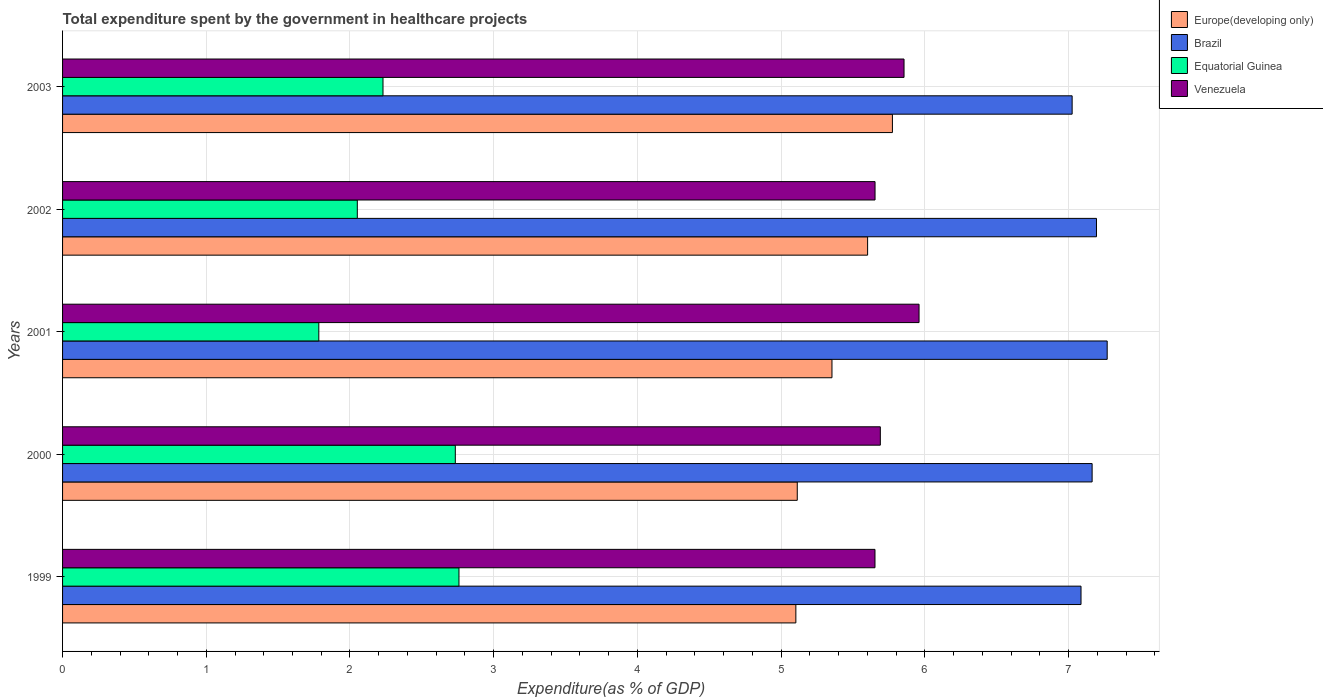How many different coloured bars are there?
Ensure brevity in your answer.  4. Are the number of bars on each tick of the Y-axis equal?
Provide a succinct answer. Yes. What is the label of the 1st group of bars from the top?
Your response must be concise. 2003. In how many cases, is the number of bars for a given year not equal to the number of legend labels?
Give a very brief answer. 0. What is the total expenditure spent by the government in healthcare projects in Equatorial Guinea in 2000?
Ensure brevity in your answer.  2.73. Across all years, what is the maximum total expenditure spent by the government in healthcare projects in Brazil?
Provide a short and direct response. 7.27. Across all years, what is the minimum total expenditure spent by the government in healthcare projects in Europe(developing only)?
Give a very brief answer. 5.1. What is the total total expenditure spent by the government in healthcare projects in Brazil in the graph?
Give a very brief answer. 35.74. What is the difference between the total expenditure spent by the government in healthcare projects in Venezuela in 2001 and that in 2003?
Provide a succinct answer. 0.1. What is the difference between the total expenditure spent by the government in healthcare projects in Brazil in 1999 and the total expenditure spent by the government in healthcare projects in Equatorial Guinea in 2002?
Keep it short and to the point. 5.04. What is the average total expenditure spent by the government in healthcare projects in Europe(developing only) per year?
Ensure brevity in your answer.  5.39. In the year 2001, what is the difference between the total expenditure spent by the government in healthcare projects in Venezuela and total expenditure spent by the government in healthcare projects in Europe(developing only)?
Your response must be concise. 0.61. In how many years, is the total expenditure spent by the government in healthcare projects in Equatorial Guinea greater than 1.4 %?
Give a very brief answer. 5. What is the ratio of the total expenditure spent by the government in healthcare projects in Europe(developing only) in 2000 to that in 2002?
Keep it short and to the point. 0.91. What is the difference between the highest and the second highest total expenditure spent by the government in healthcare projects in Europe(developing only)?
Offer a terse response. 0.17. What is the difference between the highest and the lowest total expenditure spent by the government in healthcare projects in Brazil?
Provide a short and direct response. 0.24. In how many years, is the total expenditure spent by the government in healthcare projects in Equatorial Guinea greater than the average total expenditure spent by the government in healthcare projects in Equatorial Guinea taken over all years?
Your answer should be very brief. 2. Is the sum of the total expenditure spent by the government in healthcare projects in Equatorial Guinea in 2000 and 2003 greater than the maximum total expenditure spent by the government in healthcare projects in Venezuela across all years?
Give a very brief answer. No. Is it the case that in every year, the sum of the total expenditure spent by the government in healthcare projects in Venezuela and total expenditure spent by the government in healthcare projects in Europe(developing only) is greater than the sum of total expenditure spent by the government in healthcare projects in Equatorial Guinea and total expenditure spent by the government in healthcare projects in Brazil?
Offer a very short reply. Yes. What does the 2nd bar from the top in 2003 represents?
Your answer should be compact. Equatorial Guinea. What does the 1st bar from the bottom in 2002 represents?
Make the answer very short. Europe(developing only). Is it the case that in every year, the sum of the total expenditure spent by the government in healthcare projects in Europe(developing only) and total expenditure spent by the government in healthcare projects in Brazil is greater than the total expenditure spent by the government in healthcare projects in Equatorial Guinea?
Make the answer very short. Yes. How many bars are there?
Your answer should be very brief. 20. Are all the bars in the graph horizontal?
Your answer should be compact. Yes. What is the difference between two consecutive major ticks on the X-axis?
Your response must be concise. 1. Does the graph contain any zero values?
Give a very brief answer. No. How many legend labels are there?
Your response must be concise. 4. What is the title of the graph?
Offer a terse response. Total expenditure spent by the government in healthcare projects. What is the label or title of the X-axis?
Offer a very short reply. Expenditure(as % of GDP). What is the label or title of the Y-axis?
Ensure brevity in your answer.  Years. What is the Expenditure(as % of GDP) in Europe(developing only) in 1999?
Keep it short and to the point. 5.1. What is the Expenditure(as % of GDP) of Brazil in 1999?
Your answer should be compact. 7.09. What is the Expenditure(as % of GDP) in Equatorial Guinea in 1999?
Give a very brief answer. 2.76. What is the Expenditure(as % of GDP) in Venezuela in 1999?
Provide a short and direct response. 5.65. What is the Expenditure(as % of GDP) in Europe(developing only) in 2000?
Provide a short and direct response. 5.11. What is the Expenditure(as % of GDP) of Brazil in 2000?
Provide a short and direct response. 7.16. What is the Expenditure(as % of GDP) in Equatorial Guinea in 2000?
Your answer should be compact. 2.73. What is the Expenditure(as % of GDP) of Venezuela in 2000?
Your answer should be very brief. 5.69. What is the Expenditure(as % of GDP) in Europe(developing only) in 2001?
Your answer should be very brief. 5.35. What is the Expenditure(as % of GDP) of Brazil in 2001?
Keep it short and to the point. 7.27. What is the Expenditure(as % of GDP) of Equatorial Guinea in 2001?
Your answer should be compact. 1.78. What is the Expenditure(as % of GDP) in Venezuela in 2001?
Offer a terse response. 5.96. What is the Expenditure(as % of GDP) in Europe(developing only) in 2002?
Ensure brevity in your answer.  5.6. What is the Expenditure(as % of GDP) in Brazil in 2002?
Ensure brevity in your answer.  7.19. What is the Expenditure(as % of GDP) of Equatorial Guinea in 2002?
Provide a succinct answer. 2.05. What is the Expenditure(as % of GDP) in Venezuela in 2002?
Give a very brief answer. 5.65. What is the Expenditure(as % of GDP) of Europe(developing only) in 2003?
Keep it short and to the point. 5.77. What is the Expenditure(as % of GDP) of Brazil in 2003?
Your answer should be compact. 7.03. What is the Expenditure(as % of GDP) in Equatorial Guinea in 2003?
Offer a very short reply. 2.23. What is the Expenditure(as % of GDP) in Venezuela in 2003?
Offer a terse response. 5.86. Across all years, what is the maximum Expenditure(as % of GDP) in Europe(developing only)?
Give a very brief answer. 5.77. Across all years, what is the maximum Expenditure(as % of GDP) of Brazil?
Your answer should be compact. 7.27. Across all years, what is the maximum Expenditure(as % of GDP) in Equatorial Guinea?
Your answer should be compact. 2.76. Across all years, what is the maximum Expenditure(as % of GDP) in Venezuela?
Make the answer very short. 5.96. Across all years, what is the minimum Expenditure(as % of GDP) in Europe(developing only)?
Make the answer very short. 5.1. Across all years, what is the minimum Expenditure(as % of GDP) in Brazil?
Give a very brief answer. 7.03. Across all years, what is the minimum Expenditure(as % of GDP) in Equatorial Guinea?
Offer a terse response. 1.78. Across all years, what is the minimum Expenditure(as % of GDP) of Venezuela?
Your answer should be very brief. 5.65. What is the total Expenditure(as % of GDP) of Europe(developing only) in the graph?
Your response must be concise. 26.95. What is the total Expenditure(as % of GDP) of Brazil in the graph?
Your answer should be compact. 35.74. What is the total Expenditure(as % of GDP) in Equatorial Guinea in the graph?
Provide a succinct answer. 11.56. What is the total Expenditure(as % of GDP) in Venezuela in the graph?
Make the answer very short. 28.81. What is the difference between the Expenditure(as % of GDP) in Europe(developing only) in 1999 and that in 2000?
Ensure brevity in your answer.  -0.01. What is the difference between the Expenditure(as % of GDP) in Brazil in 1999 and that in 2000?
Ensure brevity in your answer.  -0.08. What is the difference between the Expenditure(as % of GDP) of Equatorial Guinea in 1999 and that in 2000?
Give a very brief answer. 0.03. What is the difference between the Expenditure(as % of GDP) in Venezuela in 1999 and that in 2000?
Give a very brief answer. -0.04. What is the difference between the Expenditure(as % of GDP) of Europe(developing only) in 1999 and that in 2001?
Provide a succinct answer. -0.25. What is the difference between the Expenditure(as % of GDP) in Brazil in 1999 and that in 2001?
Provide a succinct answer. -0.18. What is the difference between the Expenditure(as % of GDP) of Equatorial Guinea in 1999 and that in 2001?
Your response must be concise. 0.98. What is the difference between the Expenditure(as % of GDP) of Venezuela in 1999 and that in 2001?
Offer a terse response. -0.31. What is the difference between the Expenditure(as % of GDP) of Europe(developing only) in 1999 and that in 2002?
Ensure brevity in your answer.  -0.5. What is the difference between the Expenditure(as % of GDP) of Brazil in 1999 and that in 2002?
Your answer should be very brief. -0.11. What is the difference between the Expenditure(as % of GDP) of Equatorial Guinea in 1999 and that in 2002?
Offer a terse response. 0.71. What is the difference between the Expenditure(as % of GDP) of Venezuela in 1999 and that in 2002?
Your response must be concise. -0. What is the difference between the Expenditure(as % of GDP) in Europe(developing only) in 1999 and that in 2003?
Offer a terse response. -0.67. What is the difference between the Expenditure(as % of GDP) in Brazil in 1999 and that in 2003?
Make the answer very short. 0.06. What is the difference between the Expenditure(as % of GDP) in Equatorial Guinea in 1999 and that in 2003?
Offer a very short reply. 0.53. What is the difference between the Expenditure(as % of GDP) of Venezuela in 1999 and that in 2003?
Provide a short and direct response. -0.2. What is the difference between the Expenditure(as % of GDP) of Europe(developing only) in 2000 and that in 2001?
Offer a very short reply. -0.24. What is the difference between the Expenditure(as % of GDP) in Brazil in 2000 and that in 2001?
Keep it short and to the point. -0.1. What is the difference between the Expenditure(as % of GDP) of Equatorial Guinea in 2000 and that in 2001?
Offer a terse response. 0.95. What is the difference between the Expenditure(as % of GDP) of Venezuela in 2000 and that in 2001?
Ensure brevity in your answer.  -0.27. What is the difference between the Expenditure(as % of GDP) of Europe(developing only) in 2000 and that in 2002?
Your answer should be compact. -0.49. What is the difference between the Expenditure(as % of GDP) in Brazil in 2000 and that in 2002?
Your answer should be very brief. -0.03. What is the difference between the Expenditure(as % of GDP) in Equatorial Guinea in 2000 and that in 2002?
Provide a short and direct response. 0.68. What is the difference between the Expenditure(as % of GDP) in Venezuela in 2000 and that in 2002?
Provide a succinct answer. 0.04. What is the difference between the Expenditure(as % of GDP) in Europe(developing only) in 2000 and that in 2003?
Make the answer very short. -0.66. What is the difference between the Expenditure(as % of GDP) in Brazil in 2000 and that in 2003?
Your response must be concise. 0.14. What is the difference between the Expenditure(as % of GDP) of Equatorial Guinea in 2000 and that in 2003?
Ensure brevity in your answer.  0.5. What is the difference between the Expenditure(as % of GDP) in Venezuela in 2000 and that in 2003?
Make the answer very short. -0.16. What is the difference between the Expenditure(as % of GDP) in Europe(developing only) in 2001 and that in 2002?
Ensure brevity in your answer.  -0.25. What is the difference between the Expenditure(as % of GDP) of Brazil in 2001 and that in 2002?
Keep it short and to the point. 0.07. What is the difference between the Expenditure(as % of GDP) of Equatorial Guinea in 2001 and that in 2002?
Offer a very short reply. -0.27. What is the difference between the Expenditure(as % of GDP) in Venezuela in 2001 and that in 2002?
Offer a very short reply. 0.31. What is the difference between the Expenditure(as % of GDP) of Europe(developing only) in 2001 and that in 2003?
Offer a very short reply. -0.42. What is the difference between the Expenditure(as % of GDP) in Brazil in 2001 and that in 2003?
Your response must be concise. 0.24. What is the difference between the Expenditure(as % of GDP) of Equatorial Guinea in 2001 and that in 2003?
Keep it short and to the point. -0.45. What is the difference between the Expenditure(as % of GDP) in Venezuela in 2001 and that in 2003?
Offer a very short reply. 0.1. What is the difference between the Expenditure(as % of GDP) in Europe(developing only) in 2002 and that in 2003?
Offer a very short reply. -0.17. What is the difference between the Expenditure(as % of GDP) in Brazil in 2002 and that in 2003?
Keep it short and to the point. 0.17. What is the difference between the Expenditure(as % of GDP) of Equatorial Guinea in 2002 and that in 2003?
Your answer should be very brief. -0.18. What is the difference between the Expenditure(as % of GDP) of Venezuela in 2002 and that in 2003?
Your answer should be very brief. -0.2. What is the difference between the Expenditure(as % of GDP) in Europe(developing only) in 1999 and the Expenditure(as % of GDP) in Brazil in 2000?
Give a very brief answer. -2.06. What is the difference between the Expenditure(as % of GDP) of Europe(developing only) in 1999 and the Expenditure(as % of GDP) of Equatorial Guinea in 2000?
Provide a succinct answer. 2.37. What is the difference between the Expenditure(as % of GDP) in Europe(developing only) in 1999 and the Expenditure(as % of GDP) in Venezuela in 2000?
Provide a short and direct response. -0.59. What is the difference between the Expenditure(as % of GDP) of Brazil in 1999 and the Expenditure(as % of GDP) of Equatorial Guinea in 2000?
Provide a short and direct response. 4.35. What is the difference between the Expenditure(as % of GDP) of Brazil in 1999 and the Expenditure(as % of GDP) of Venezuela in 2000?
Ensure brevity in your answer.  1.4. What is the difference between the Expenditure(as % of GDP) in Equatorial Guinea in 1999 and the Expenditure(as % of GDP) in Venezuela in 2000?
Provide a short and direct response. -2.93. What is the difference between the Expenditure(as % of GDP) of Europe(developing only) in 1999 and the Expenditure(as % of GDP) of Brazil in 2001?
Offer a very short reply. -2.17. What is the difference between the Expenditure(as % of GDP) of Europe(developing only) in 1999 and the Expenditure(as % of GDP) of Equatorial Guinea in 2001?
Provide a succinct answer. 3.32. What is the difference between the Expenditure(as % of GDP) of Europe(developing only) in 1999 and the Expenditure(as % of GDP) of Venezuela in 2001?
Ensure brevity in your answer.  -0.86. What is the difference between the Expenditure(as % of GDP) of Brazil in 1999 and the Expenditure(as % of GDP) of Equatorial Guinea in 2001?
Your answer should be compact. 5.3. What is the difference between the Expenditure(as % of GDP) in Brazil in 1999 and the Expenditure(as % of GDP) in Venezuela in 2001?
Your answer should be compact. 1.13. What is the difference between the Expenditure(as % of GDP) in Equatorial Guinea in 1999 and the Expenditure(as % of GDP) in Venezuela in 2001?
Your answer should be very brief. -3.2. What is the difference between the Expenditure(as % of GDP) in Europe(developing only) in 1999 and the Expenditure(as % of GDP) in Brazil in 2002?
Ensure brevity in your answer.  -2.09. What is the difference between the Expenditure(as % of GDP) in Europe(developing only) in 1999 and the Expenditure(as % of GDP) in Equatorial Guinea in 2002?
Your answer should be very brief. 3.05. What is the difference between the Expenditure(as % of GDP) of Europe(developing only) in 1999 and the Expenditure(as % of GDP) of Venezuela in 2002?
Offer a very short reply. -0.55. What is the difference between the Expenditure(as % of GDP) in Brazil in 1999 and the Expenditure(as % of GDP) in Equatorial Guinea in 2002?
Offer a very short reply. 5.04. What is the difference between the Expenditure(as % of GDP) in Brazil in 1999 and the Expenditure(as % of GDP) in Venezuela in 2002?
Provide a succinct answer. 1.43. What is the difference between the Expenditure(as % of GDP) of Equatorial Guinea in 1999 and the Expenditure(as % of GDP) of Venezuela in 2002?
Your answer should be compact. -2.9. What is the difference between the Expenditure(as % of GDP) in Europe(developing only) in 1999 and the Expenditure(as % of GDP) in Brazil in 2003?
Offer a terse response. -1.92. What is the difference between the Expenditure(as % of GDP) in Europe(developing only) in 1999 and the Expenditure(as % of GDP) in Equatorial Guinea in 2003?
Your answer should be compact. 2.87. What is the difference between the Expenditure(as % of GDP) of Europe(developing only) in 1999 and the Expenditure(as % of GDP) of Venezuela in 2003?
Your answer should be compact. -0.75. What is the difference between the Expenditure(as % of GDP) in Brazil in 1999 and the Expenditure(as % of GDP) in Equatorial Guinea in 2003?
Provide a succinct answer. 4.86. What is the difference between the Expenditure(as % of GDP) of Brazil in 1999 and the Expenditure(as % of GDP) of Venezuela in 2003?
Provide a short and direct response. 1.23. What is the difference between the Expenditure(as % of GDP) in Equatorial Guinea in 1999 and the Expenditure(as % of GDP) in Venezuela in 2003?
Offer a terse response. -3.1. What is the difference between the Expenditure(as % of GDP) of Europe(developing only) in 2000 and the Expenditure(as % of GDP) of Brazil in 2001?
Your answer should be compact. -2.16. What is the difference between the Expenditure(as % of GDP) in Europe(developing only) in 2000 and the Expenditure(as % of GDP) in Equatorial Guinea in 2001?
Your answer should be compact. 3.33. What is the difference between the Expenditure(as % of GDP) in Europe(developing only) in 2000 and the Expenditure(as % of GDP) in Venezuela in 2001?
Ensure brevity in your answer.  -0.85. What is the difference between the Expenditure(as % of GDP) of Brazil in 2000 and the Expenditure(as % of GDP) of Equatorial Guinea in 2001?
Offer a very short reply. 5.38. What is the difference between the Expenditure(as % of GDP) of Brazil in 2000 and the Expenditure(as % of GDP) of Venezuela in 2001?
Keep it short and to the point. 1.2. What is the difference between the Expenditure(as % of GDP) of Equatorial Guinea in 2000 and the Expenditure(as % of GDP) of Venezuela in 2001?
Offer a terse response. -3.23. What is the difference between the Expenditure(as % of GDP) in Europe(developing only) in 2000 and the Expenditure(as % of GDP) in Brazil in 2002?
Your response must be concise. -2.08. What is the difference between the Expenditure(as % of GDP) of Europe(developing only) in 2000 and the Expenditure(as % of GDP) of Equatorial Guinea in 2002?
Your answer should be compact. 3.06. What is the difference between the Expenditure(as % of GDP) in Europe(developing only) in 2000 and the Expenditure(as % of GDP) in Venezuela in 2002?
Offer a terse response. -0.54. What is the difference between the Expenditure(as % of GDP) of Brazil in 2000 and the Expenditure(as % of GDP) of Equatorial Guinea in 2002?
Ensure brevity in your answer.  5.11. What is the difference between the Expenditure(as % of GDP) in Brazil in 2000 and the Expenditure(as % of GDP) in Venezuela in 2002?
Provide a short and direct response. 1.51. What is the difference between the Expenditure(as % of GDP) in Equatorial Guinea in 2000 and the Expenditure(as % of GDP) in Venezuela in 2002?
Provide a succinct answer. -2.92. What is the difference between the Expenditure(as % of GDP) in Europe(developing only) in 2000 and the Expenditure(as % of GDP) in Brazil in 2003?
Ensure brevity in your answer.  -1.91. What is the difference between the Expenditure(as % of GDP) in Europe(developing only) in 2000 and the Expenditure(as % of GDP) in Equatorial Guinea in 2003?
Provide a short and direct response. 2.88. What is the difference between the Expenditure(as % of GDP) of Europe(developing only) in 2000 and the Expenditure(as % of GDP) of Venezuela in 2003?
Your answer should be very brief. -0.74. What is the difference between the Expenditure(as % of GDP) in Brazil in 2000 and the Expenditure(as % of GDP) in Equatorial Guinea in 2003?
Provide a succinct answer. 4.93. What is the difference between the Expenditure(as % of GDP) in Brazil in 2000 and the Expenditure(as % of GDP) in Venezuela in 2003?
Offer a terse response. 1.31. What is the difference between the Expenditure(as % of GDP) of Equatorial Guinea in 2000 and the Expenditure(as % of GDP) of Venezuela in 2003?
Make the answer very short. -3.12. What is the difference between the Expenditure(as % of GDP) in Europe(developing only) in 2001 and the Expenditure(as % of GDP) in Brazil in 2002?
Provide a succinct answer. -1.84. What is the difference between the Expenditure(as % of GDP) of Europe(developing only) in 2001 and the Expenditure(as % of GDP) of Equatorial Guinea in 2002?
Your response must be concise. 3.3. What is the difference between the Expenditure(as % of GDP) in Europe(developing only) in 2001 and the Expenditure(as % of GDP) in Venezuela in 2002?
Your answer should be compact. -0.3. What is the difference between the Expenditure(as % of GDP) in Brazil in 2001 and the Expenditure(as % of GDP) in Equatorial Guinea in 2002?
Offer a terse response. 5.22. What is the difference between the Expenditure(as % of GDP) in Brazil in 2001 and the Expenditure(as % of GDP) in Venezuela in 2002?
Keep it short and to the point. 1.62. What is the difference between the Expenditure(as % of GDP) of Equatorial Guinea in 2001 and the Expenditure(as % of GDP) of Venezuela in 2002?
Your answer should be compact. -3.87. What is the difference between the Expenditure(as % of GDP) in Europe(developing only) in 2001 and the Expenditure(as % of GDP) in Brazil in 2003?
Make the answer very short. -1.67. What is the difference between the Expenditure(as % of GDP) of Europe(developing only) in 2001 and the Expenditure(as % of GDP) of Equatorial Guinea in 2003?
Your response must be concise. 3.12. What is the difference between the Expenditure(as % of GDP) of Europe(developing only) in 2001 and the Expenditure(as % of GDP) of Venezuela in 2003?
Your response must be concise. -0.5. What is the difference between the Expenditure(as % of GDP) of Brazil in 2001 and the Expenditure(as % of GDP) of Equatorial Guinea in 2003?
Offer a terse response. 5.04. What is the difference between the Expenditure(as % of GDP) of Brazil in 2001 and the Expenditure(as % of GDP) of Venezuela in 2003?
Offer a very short reply. 1.41. What is the difference between the Expenditure(as % of GDP) of Equatorial Guinea in 2001 and the Expenditure(as % of GDP) of Venezuela in 2003?
Make the answer very short. -4.07. What is the difference between the Expenditure(as % of GDP) in Europe(developing only) in 2002 and the Expenditure(as % of GDP) in Brazil in 2003?
Make the answer very short. -1.42. What is the difference between the Expenditure(as % of GDP) of Europe(developing only) in 2002 and the Expenditure(as % of GDP) of Equatorial Guinea in 2003?
Give a very brief answer. 3.37. What is the difference between the Expenditure(as % of GDP) of Europe(developing only) in 2002 and the Expenditure(as % of GDP) of Venezuela in 2003?
Give a very brief answer. -0.25. What is the difference between the Expenditure(as % of GDP) of Brazil in 2002 and the Expenditure(as % of GDP) of Equatorial Guinea in 2003?
Offer a terse response. 4.96. What is the difference between the Expenditure(as % of GDP) in Brazil in 2002 and the Expenditure(as % of GDP) in Venezuela in 2003?
Offer a very short reply. 1.34. What is the difference between the Expenditure(as % of GDP) of Equatorial Guinea in 2002 and the Expenditure(as % of GDP) of Venezuela in 2003?
Give a very brief answer. -3.8. What is the average Expenditure(as % of GDP) of Europe(developing only) per year?
Provide a succinct answer. 5.39. What is the average Expenditure(as % of GDP) of Brazil per year?
Offer a very short reply. 7.15. What is the average Expenditure(as % of GDP) of Equatorial Guinea per year?
Offer a very short reply. 2.31. What is the average Expenditure(as % of GDP) of Venezuela per year?
Provide a succinct answer. 5.76. In the year 1999, what is the difference between the Expenditure(as % of GDP) in Europe(developing only) and Expenditure(as % of GDP) in Brazil?
Offer a terse response. -1.98. In the year 1999, what is the difference between the Expenditure(as % of GDP) of Europe(developing only) and Expenditure(as % of GDP) of Equatorial Guinea?
Your answer should be very brief. 2.34. In the year 1999, what is the difference between the Expenditure(as % of GDP) in Europe(developing only) and Expenditure(as % of GDP) in Venezuela?
Make the answer very short. -0.55. In the year 1999, what is the difference between the Expenditure(as % of GDP) in Brazil and Expenditure(as % of GDP) in Equatorial Guinea?
Provide a succinct answer. 4.33. In the year 1999, what is the difference between the Expenditure(as % of GDP) of Brazil and Expenditure(as % of GDP) of Venezuela?
Keep it short and to the point. 1.43. In the year 1999, what is the difference between the Expenditure(as % of GDP) in Equatorial Guinea and Expenditure(as % of GDP) in Venezuela?
Give a very brief answer. -2.89. In the year 2000, what is the difference between the Expenditure(as % of GDP) of Europe(developing only) and Expenditure(as % of GDP) of Brazil?
Offer a terse response. -2.05. In the year 2000, what is the difference between the Expenditure(as % of GDP) in Europe(developing only) and Expenditure(as % of GDP) in Equatorial Guinea?
Ensure brevity in your answer.  2.38. In the year 2000, what is the difference between the Expenditure(as % of GDP) of Europe(developing only) and Expenditure(as % of GDP) of Venezuela?
Provide a short and direct response. -0.58. In the year 2000, what is the difference between the Expenditure(as % of GDP) in Brazil and Expenditure(as % of GDP) in Equatorial Guinea?
Your response must be concise. 4.43. In the year 2000, what is the difference between the Expenditure(as % of GDP) in Brazil and Expenditure(as % of GDP) in Venezuela?
Your response must be concise. 1.47. In the year 2000, what is the difference between the Expenditure(as % of GDP) in Equatorial Guinea and Expenditure(as % of GDP) in Venezuela?
Keep it short and to the point. -2.96. In the year 2001, what is the difference between the Expenditure(as % of GDP) of Europe(developing only) and Expenditure(as % of GDP) of Brazil?
Your response must be concise. -1.92. In the year 2001, what is the difference between the Expenditure(as % of GDP) in Europe(developing only) and Expenditure(as % of GDP) in Equatorial Guinea?
Keep it short and to the point. 3.57. In the year 2001, what is the difference between the Expenditure(as % of GDP) of Europe(developing only) and Expenditure(as % of GDP) of Venezuela?
Your response must be concise. -0.61. In the year 2001, what is the difference between the Expenditure(as % of GDP) in Brazil and Expenditure(as % of GDP) in Equatorial Guinea?
Your response must be concise. 5.49. In the year 2001, what is the difference between the Expenditure(as % of GDP) of Brazil and Expenditure(as % of GDP) of Venezuela?
Your answer should be very brief. 1.31. In the year 2001, what is the difference between the Expenditure(as % of GDP) of Equatorial Guinea and Expenditure(as % of GDP) of Venezuela?
Your answer should be compact. -4.18. In the year 2002, what is the difference between the Expenditure(as % of GDP) of Europe(developing only) and Expenditure(as % of GDP) of Brazil?
Your answer should be compact. -1.59. In the year 2002, what is the difference between the Expenditure(as % of GDP) of Europe(developing only) and Expenditure(as % of GDP) of Equatorial Guinea?
Make the answer very short. 3.55. In the year 2002, what is the difference between the Expenditure(as % of GDP) in Europe(developing only) and Expenditure(as % of GDP) in Venezuela?
Ensure brevity in your answer.  -0.05. In the year 2002, what is the difference between the Expenditure(as % of GDP) of Brazil and Expenditure(as % of GDP) of Equatorial Guinea?
Provide a succinct answer. 5.14. In the year 2002, what is the difference between the Expenditure(as % of GDP) of Brazil and Expenditure(as % of GDP) of Venezuela?
Make the answer very short. 1.54. In the year 2002, what is the difference between the Expenditure(as % of GDP) in Equatorial Guinea and Expenditure(as % of GDP) in Venezuela?
Provide a short and direct response. -3.6. In the year 2003, what is the difference between the Expenditure(as % of GDP) of Europe(developing only) and Expenditure(as % of GDP) of Brazil?
Keep it short and to the point. -1.25. In the year 2003, what is the difference between the Expenditure(as % of GDP) in Europe(developing only) and Expenditure(as % of GDP) in Equatorial Guinea?
Your response must be concise. 3.54. In the year 2003, what is the difference between the Expenditure(as % of GDP) in Europe(developing only) and Expenditure(as % of GDP) in Venezuela?
Offer a terse response. -0.08. In the year 2003, what is the difference between the Expenditure(as % of GDP) of Brazil and Expenditure(as % of GDP) of Equatorial Guinea?
Give a very brief answer. 4.8. In the year 2003, what is the difference between the Expenditure(as % of GDP) of Brazil and Expenditure(as % of GDP) of Venezuela?
Your response must be concise. 1.17. In the year 2003, what is the difference between the Expenditure(as % of GDP) of Equatorial Guinea and Expenditure(as % of GDP) of Venezuela?
Your answer should be very brief. -3.63. What is the ratio of the Expenditure(as % of GDP) in Equatorial Guinea in 1999 to that in 2000?
Give a very brief answer. 1.01. What is the ratio of the Expenditure(as % of GDP) of Venezuela in 1999 to that in 2000?
Provide a succinct answer. 0.99. What is the ratio of the Expenditure(as % of GDP) of Europe(developing only) in 1999 to that in 2001?
Make the answer very short. 0.95. What is the ratio of the Expenditure(as % of GDP) in Brazil in 1999 to that in 2001?
Provide a short and direct response. 0.97. What is the ratio of the Expenditure(as % of GDP) of Equatorial Guinea in 1999 to that in 2001?
Keep it short and to the point. 1.55. What is the ratio of the Expenditure(as % of GDP) of Venezuela in 1999 to that in 2001?
Your response must be concise. 0.95. What is the ratio of the Expenditure(as % of GDP) in Europe(developing only) in 1999 to that in 2002?
Ensure brevity in your answer.  0.91. What is the ratio of the Expenditure(as % of GDP) of Brazil in 1999 to that in 2002?
Give a very brief answer. 0.98. What is the ratio of the Expenditure(as % of GDP) of Equatorial Guinea in 1999 to that in 2002?
Offer a terse response. 1.34. What is the ratio of the Expenditure(as % of GDP) in Venezuela in 1999 to that in 2002?
Keep it short and to the point. 1. What is the ratio of the Expenditure(as % of GDP) in Europe(developing only) in 1999 to that in 2003?
Give a very brief answer. 0.88. What is the ratio of the Expenditure(as % of GDP) of Brazil in 1999 to that in 2003?
Make the answer very short. 1.01. What is the ratio of the Expenditure(as % of GDP) in Equatorial Guinea in 1999 to that in 2003?
Make the answer very short. 1.24. What is the ratio of the Expenditure(as % of GDP) of Venezuela in 1999 to that in 2003?
Provide a short and direct response. 0.97. What is the ratio of the Expenditure(as % of GDP) of Europe(developing only) in 2000 to that in 2001?
Ensure brevity in your answer.  0.95. What is the ratio of the Expenditure(as % of GDP) in Brazil in 2000 to that in 2001?
Provide a short and direct response. 0.99. What is the ratio of the Expenditure(as % of GDP) in Equatorial Guinea in 2000 to that in 2001?
Offer a terse response. 1.53. What is the ratio of the Expenditure(as % of GDP) in Venezuela in 2000 to that in 2001?
Offer a terse response. 0.95. What is the ratio of the Expenditure(as % of GDP) of Europe(developing only) in 2000 to that in 2002?
Ensure brevity in your answer.  0.91. What is the ratio of the Expenditure(as % of GDP) in Equatorial Guinea in 2000 to that in 2002?
Your answer should be compact. 1.33. What is the ratio of the Expenditure(as % of GDP) of Europe(developing only) in 2000 to that in 2003?
Offer a terse response. 0.89. What is the ratio of the Expenditure(as % of GDP) in Brazil in 2000 to that in 2003?
Offer a very short reply. 1.02. What is the ratio of the Expenditure(as % of GDP) in Equatorial Guinea in 2000 to that in 2003?
Keep it short and to the point. 1.23. What is the ratio of the Expenditure(as % of GDP) of Venezuela in 2000 to that in 2003?
Make the answer very short. 0.97. What is the ratio of the Expenditure(as % of GDP) of Europe(developing only) in 2001 to that in 2002?
Keep it short and to the point. 0.96. What is the ratio of the Expenditure(as % of GDP) in Brazil in 2001 to that in 2002?
Offer a terse response. 1.01. What is the ratio of the Expenditure(as % of GDP) in Equatorial Guinea in 2001 to that in 2002?
Your answer should be compact. 0.87. What is the ratio of the Expenditure(as % of GDP) of Venezuela in 2001 to that in 2002?
Provide a succinct answer. 1.05. What is the ratio of the Expenditure(as % of GDP) in Europe(developing only) in 2001 to that in 2003?
Your answer should be compact. 0.93. What is the ratio of the Expenditure(as % of GDP) in Brazil in 2001 to that in 2003?
Your answer should be very brief. 1.03. What is the ratio of the Expenditure(as % of GDP) in Equatorial Guinea in 2001 to that in 2003?
Your answer should be very brief. 0.8. What is the ratio of the Expenditure(as % of GDP) of Venezuela in 2001 to that in 2003?
Offer a terse response. 1.02. What is the ratio of the Expenditure(as % of GDP) in Europe(developing only) in 2002 to that in 2003?
Offer a terse response. 0.97. What is the ratio of the Expenditure(as % of GDP) of Brazil in 2002 to that in 2003?
Keep it short and to the point. 1.02. What is the ratio of the Expenditure(as % of GDP) in Equatorial Guinea in 2002 to that in 2003?
Make the answer very short. 0.92. What is the ratio of the Expenditure(as % of GDP) of Venezuela in 2002 to that in 2003?
Ensure brevity in your answer.  0.97. What is the difference between the highest and the second highest Expenditure(as % of GDP) of Europe(developing only)?
Give a very brief answer. 0.17. What is the difference between the highest and the second highest Expenditure(as % of GDP) in Brazil?
Your answer should be very brief. 0.07. What is the difference between the highest and the second highest Expenditure(as % of GDP) in Equatorial Guinea?
Keep it short and to the point. 0.03. What is the difference between the highest and the second highest Expenditure(as % of GDP) of Venezuela?
Ensure brevity in your answer.  0.1. What is the difference between the highest and the lowest Expenditure(as % of GDP) in Europe(developing only)?
Your answer should be compact. 0.67. What is the difference between the highest and the lowest Expenditure(as % of GDP) of Brazil?
Offer a terse response. 0.24. What is the difference between the highest and the lowest Expenditure(as % of GDP) of Equatorial Guinea?
Provide a short and direct response. 0.98. What is the difference between the highest and the lowest Expenditure(as % of GDP) of Venezuela?
Your answer should be very brief. 0.31. 